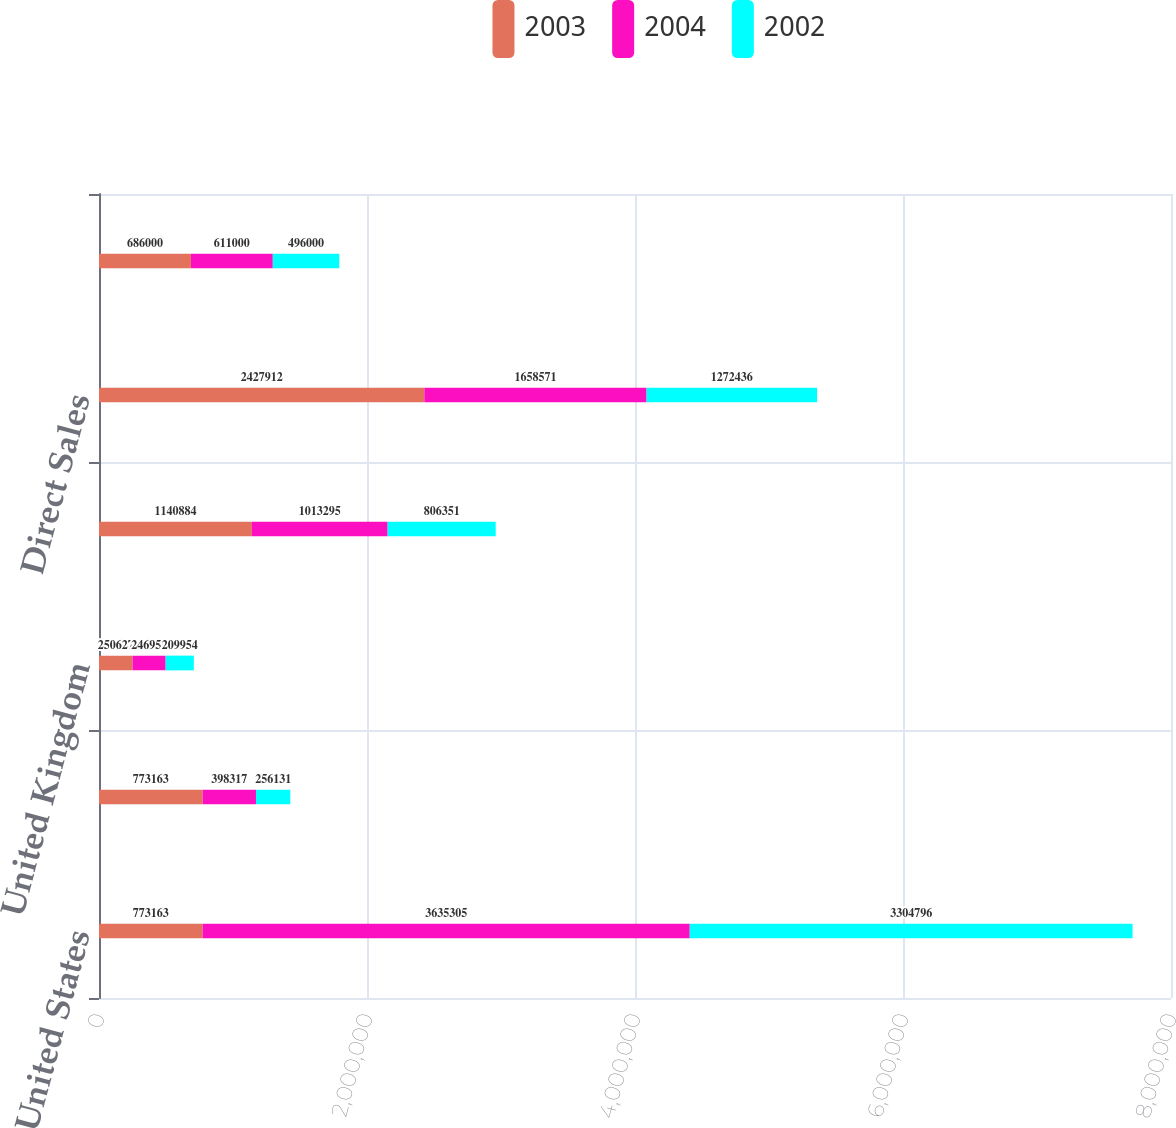Convert chart. <chart><loc_0><loc_0><loc_500><loc_500><stacked_bar_chart><ecel><fcel>United States<fcel>Germany<fcel>United Kingdom<fcel>All other<fcel>Direct Sales<fcel>Exports<nl><fcel>2003<fcel>773163<fcel>773163<fcel>250627<fcel>1.14088e+06<fcel>2.42791e+06<fcel>686000<nl><fcel>2004<fcel>3.6353e+06<fcel>398317<fcel>246959<fcel>1.0133e+06<fcel>1.65857e+06<fcel>611000<nl><fcel>2002<fcel>3.3048e+06<fcel>256131<fcel>209954<fcel>806351<fcel>1.27244e+06<fcel>496000<nl></chart> 